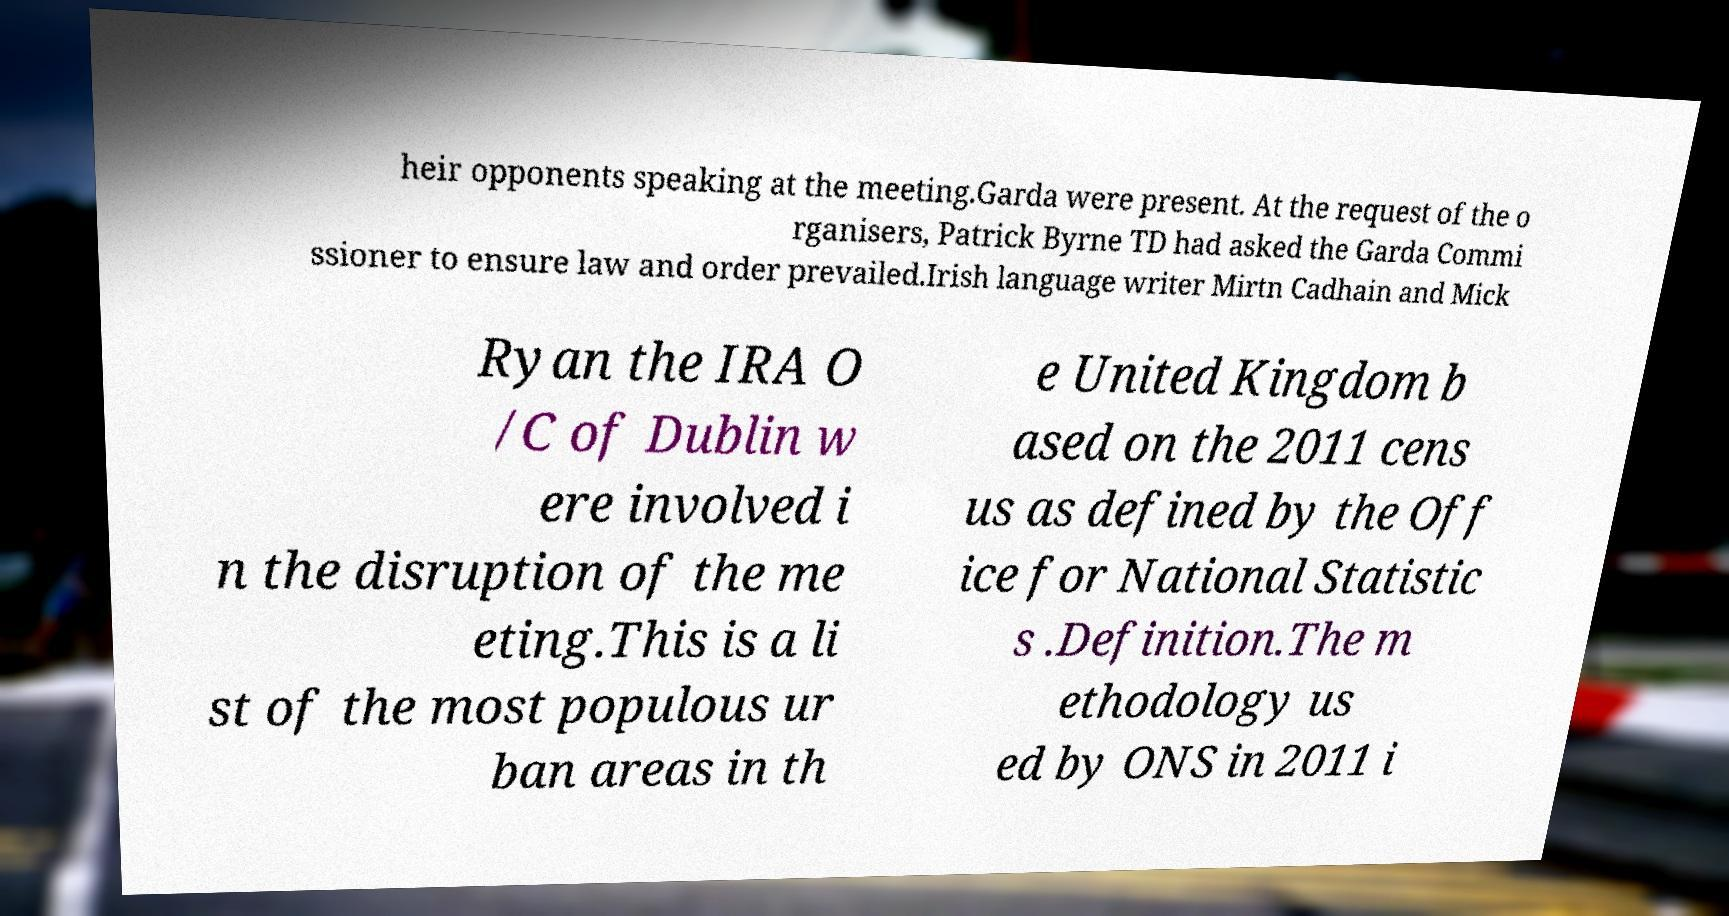Can you accurately transcribe the text from the provided image for me? heir opponents speaking at the meeting.Garda were present. At the request of the o rganisers, Patrick Byrne TD had asked the Garda Commi ssioner to ensure law and order prevailed.Irish language writer Mirtn Cadhain and Mick Ryan the IRA O /C of Dublin w ere involved i n the disruption of the me eting.This is a li st of the most populous ur ban areas in th e United Kingdom b ased on the 2011 cens us as defined by the Off ice for National Statistic s .Definition.The m ethodology us ed by ONS in 2011 i 